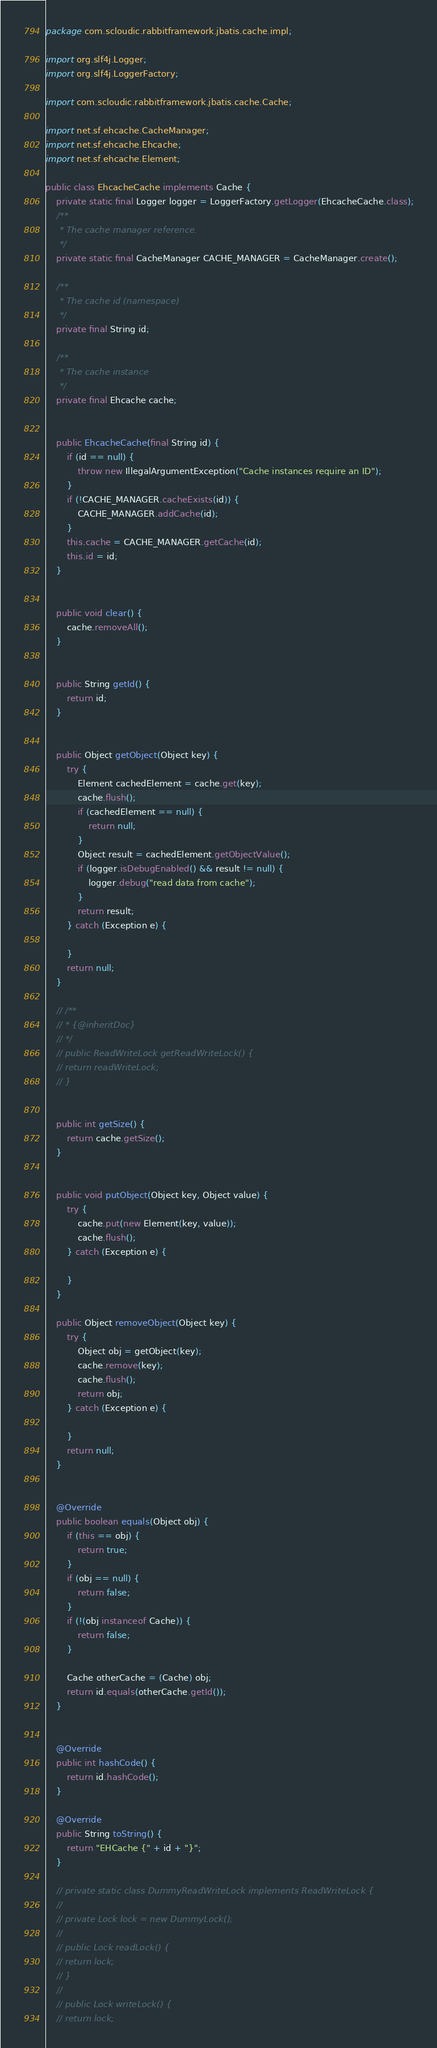Convert code to text. <code><loc_0><loc_0><loc_500><loc_500><_Java_>package com.scloudic.rabbitframework.jbatis.cache.impl;

import org.slf4j.Logger;
import org.slf4j.LoggerFactory;

import com.scloudic.rabbitframework.jbatis.cache.Cache;

import net.sf.ehcache.CacheManager;
import net.sf.ehcache.Ehcache;
import net.sf.ehcache.Element;

public class EhcacheCache implements Cache {
    private static final Logger logger = LoggerFactory.getLogger(EhcacheCache.class);
    /**
     * The cache manager reference.
     */
    private static final CacheManager CACHE_MANAGER = CacheManager.create();

    /**
     * The cache id (namespace)
     */
    private final String id;

    /**
     * The cache instance
     */
    private final Ehcache cache;


    public EhcacheCache(final String id) {
        if (id == null) {
            throw new IllegalArgumentException("Cache instances require an ID");
        }
        if (!CACHE_MANAGER.cacheExists(id)) {
            CACHE_MANAGER.addCache(id);
        }
        this.cache = CACHE_MANAGER.getCache(id);
        this.id = id;
    }


    public void clear() {
        cache.removeAll();
    }


    public String getId() {
        return id;
    }


    public Object getObject(Object key) {
        try {
            Element cachedElement = cache.get(key);
            cache.flush();
            if (cachedElement == null) {
                return null;
            }
            Object result = cachedElement.getObjectValue();
            if (logger.isDebugEnabled() && result != null) {
                logger.debug("read data from cache");
            }
            return result;
        } catch (Exception e) {

        }
        return null;
    }

    // /**
    // * {@inheritDoc}
    // */
    // public ReadWriteLock getReadWriteLock() {
    // return readWriteLock;
    // }


    public int getSize() {
        return cache.getSize();
    }


    public void putObject(Object key, Object value) {
        try {
            cache.put(new Element(key, value));
            cache.flush();
        } catch (Exception e) {

        }
    }

    public Object removeObject(Object key) {
        try {
            Object obj = getObject(key);
            cache.remove(key);
            cache.flush();
            return obj;
        } catch (Exception e) {

        }
        return null;
    }


    @Override
    public boolean equals(Object obj) {
        if (this == obj) {
            return true;
        }
        if (obj == null) {
            return false;
        }
        if (!(obj instanceof Cache)) {
            return false;
        }

        Cache otherCache = (Cache) obj;
        return id.equals(otherCache.getId());
    }


    @Override
    public int hashCode() {
        return id.hashCode();
    }

    @Override
    public String toString() {
        return "EHCache {" + id + "}";
    }

    // private static class DummyReadWriteLock implements ReadWriteLock {
    //
    // private Lock lock = new DummyLock();
    //
    // public Lock readLock() {
    // return lock;
    // }
    //
    // public Lock writeLock() {
    // return lock;</code> 